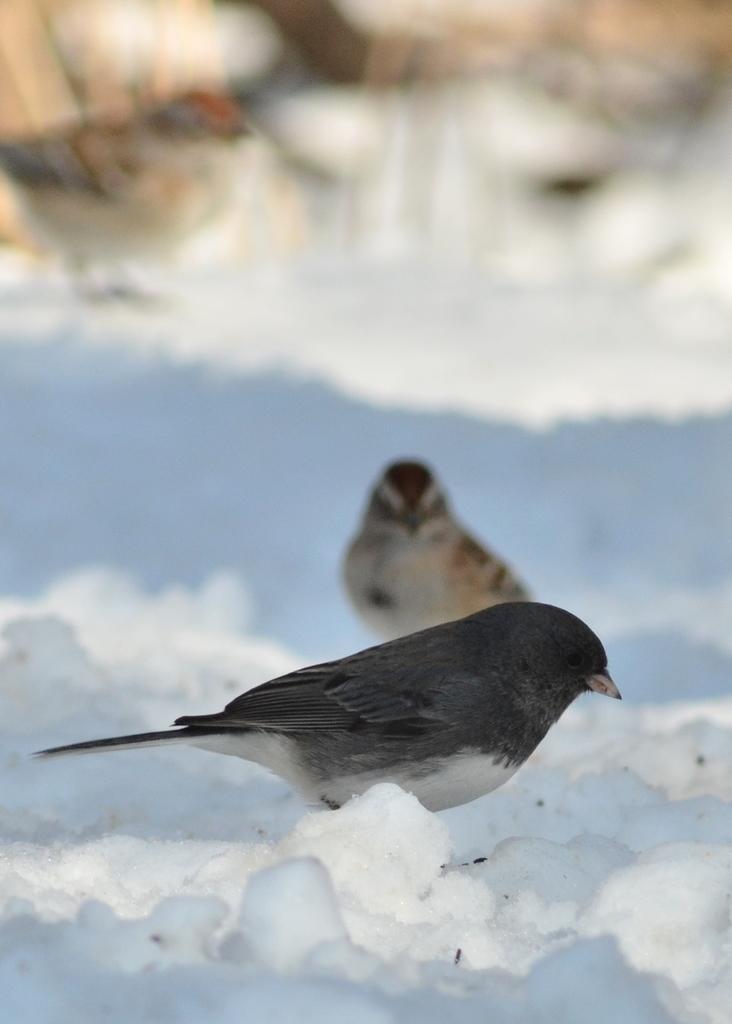In one or two sentences, can you explain what this image depicts? In this picture we can see some birds are in ice. 